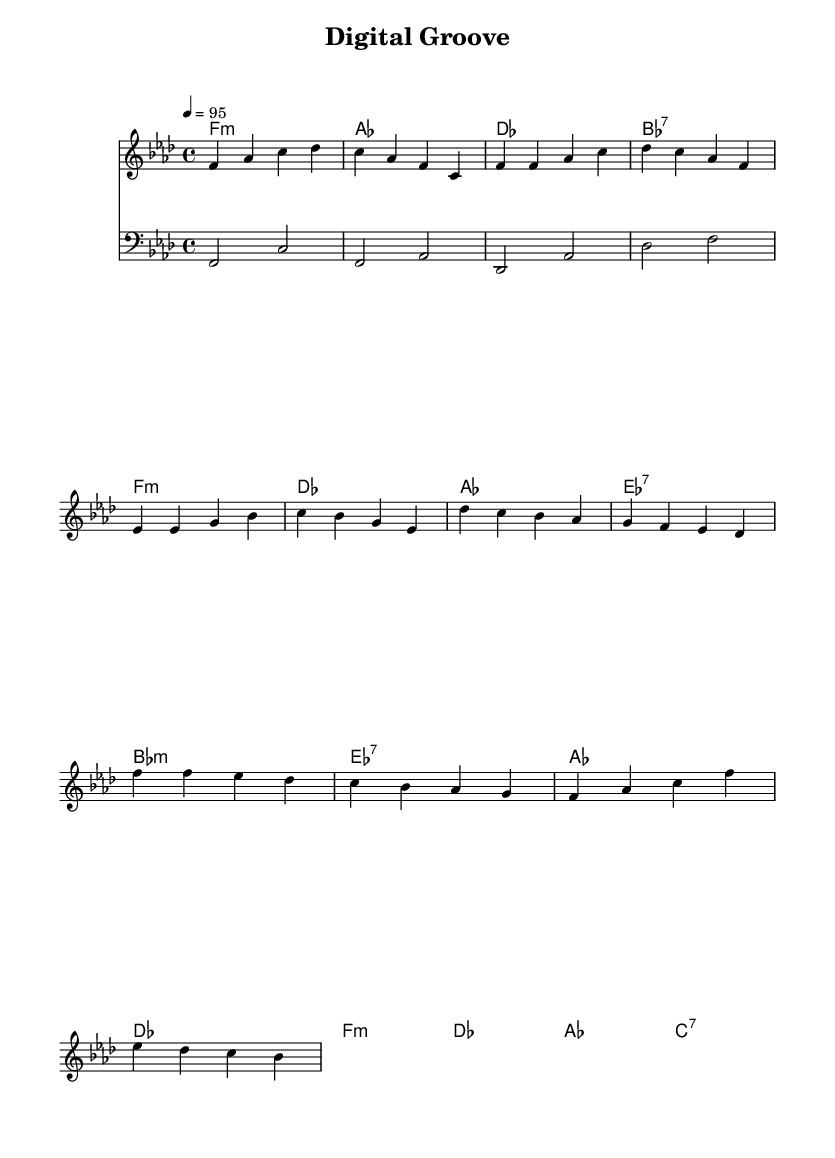What is the key signature of this music? The key signature is identified by looking at the beginning of the staff, where the flats or sharps are indicated. In this piece, there is one flat, which is B flat, indicating that the key is F minor.
Answer: F minor What is the time signature of this music? The time signature is found next to the key signature, which shows how many beats are in a measure. Here, the time signature is 4/4, meaning there are four beats per measure.
Answer: 4/4 What is the tempo of this music? The tempo is marked at the beginning of the score, indicated by the note value and beats per minute. In this piece, it is set to 95 beats per minute, meaning it is moderately paced.
Answer: 95 What is the first chord in the piece? To find the first chord, you look at the chord lines at the beginning of the score. The first chord mentioned is F minor, represented by f:m.
Answer: F minor How many measures are there in the pre-chorus section? The pre-chorus section is noted in the melody, and by counting the measures within that segment, there are four measures in total before transitioning to the chorus.
Answer: 4 Which chord follows the E flat 7 chord in the pre-chorus? In the chord progression for the pre-chorus, the E flat 7 chord is followed by the A flat chord. This can be confirmed by observing the sequence of chords directly after E flat 7.
Answer: A flat What is the bass note played during the chorus? The bass line consists of notes played in sync with the chords. During the chorus, the lowest note played starts from E flat, which is the first bass note of this section.
Answer: E flat 